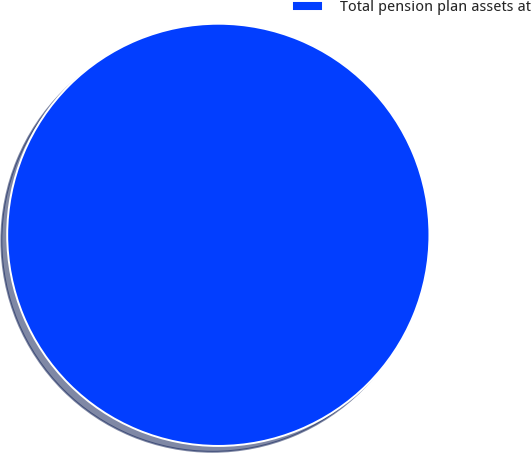Convert chart. <chart><loc_0><loc_0><loc_500><loc_500><pie_chart><fcel>Total pension plan assets at<nl><fcel>100.0%<nl></chart> 